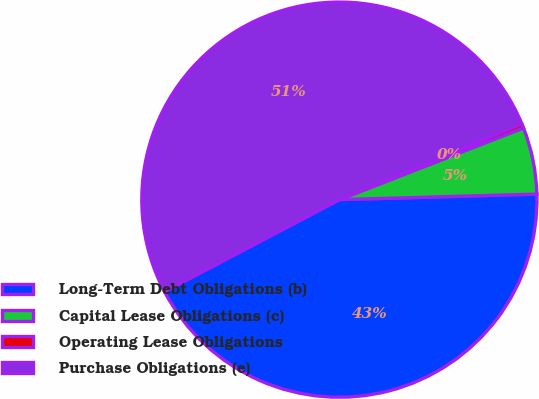<chart> <loc_0><loc_0><loc_500><loc_500><pie_chart><fcel>Long-Term Debt Obligations (b)<fcel>Capital Lease Obligations (c)<fcel>Operating Lease Obligations<fcel>Purchase Obligations (e)<nl><fcel>42.73%<fcel>5.47%<fcel>0.36%<fcel>51.43%<nl></chart> 